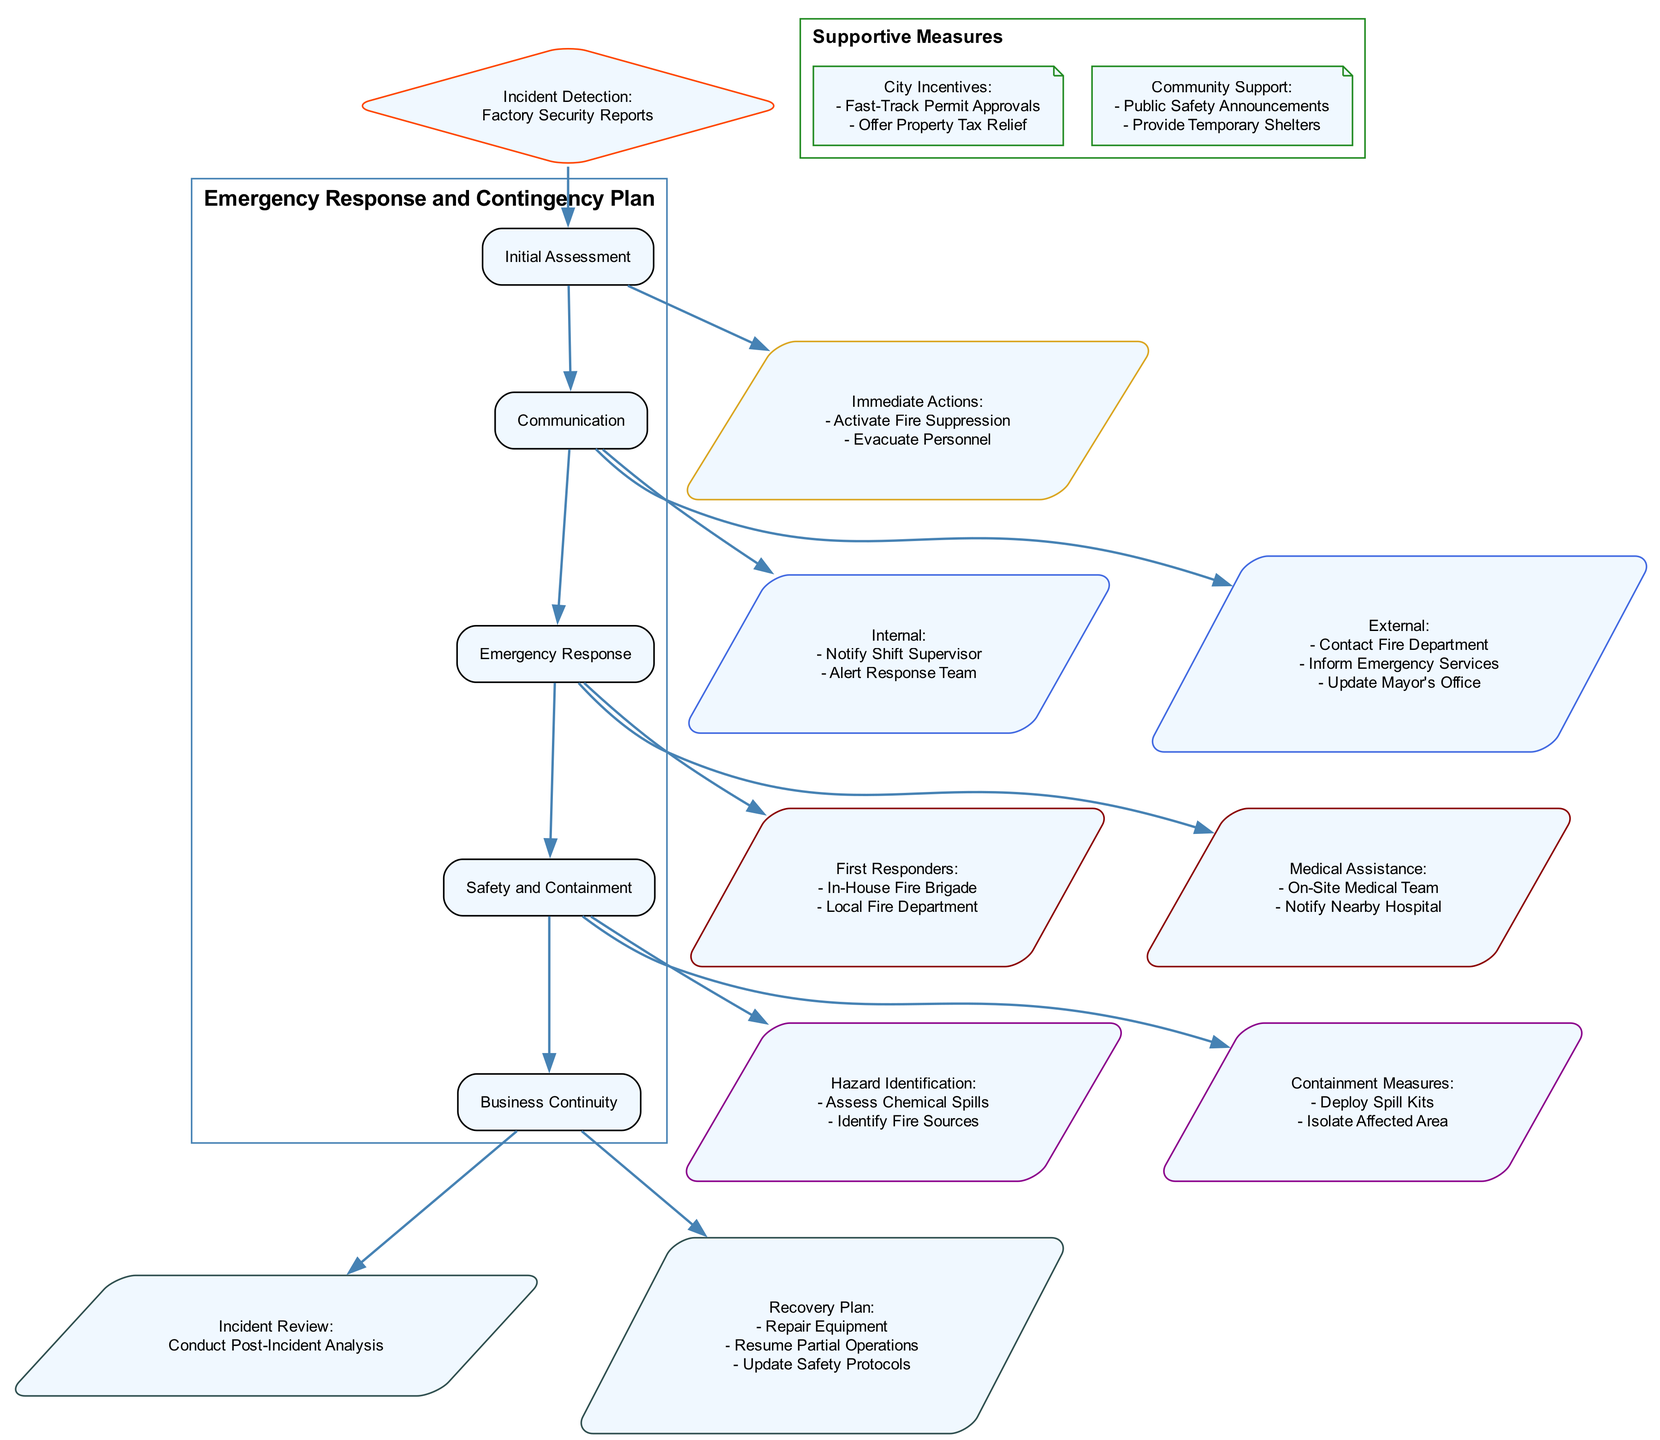What is the first action taken after incident detection? The first action after incident detection is to "Activate Fire Suppression Systems." This is listed under Immediate Actions that follow the Incident Detection node.
Answer: Activate Fire Suppression Systems How many main processes are in the diagram? The diagram has five main processes: Initial Assessment, Communication, Emergency Response, Safety and Containment, and Business Continuity. These can be counted from the main node section of the diagram.
Answer: 5 What will the city offer as part of the supportive measures? The city will offer "Fast-Track Permit Approvals" and "Offer Property Tax Relief" as part of the City Incentives. This information is noted in the Supportive Measures section of the diagram.
Answer: Fast-Track Permit Approvals, Offer Property Tax Relief Which node follows Emergency Response? The node that follows Emergency Response is Safety and Containment. The edge from Emergency Response points directly to this node in the flow of the diagram.
Answer: Safety and Containment What type of team is notified as part of the internal communication? The In-House Response Team is notified as part of the internal communication when an incident occurs. This is specifically mentioned in the Internal Communication section.
Answer: In-House Response Team What are the first responders identified in the Emergency Response plan? The first responders identified are the In-House Fire Brigade and the Local Fire Department. This information is presented in the Emergency Response section of the diagram.
Answer: In-House Fire Brigade, Local Fire Department What does the recovery plan include? The recovery plan includes "Repair Damaged Equipment," "Resume Partial Operations," and "Review and Update Safety Protocols." These actions are detailed in the Recovery Plan node under Business Continuity.
Answer: Repair Damaged Equipment, Resume Partial Operations, Review and Update Safety Protocols What is the role of the local fire department in the communication plan? The local fire department's role is to be contacted as part of the external communication during an incident. This task is specifically listed in the External Communication section of the diagram.
Answer: Contact Local Fire Department How are hazardous situations identified during an emergency? Hazardous situations are identified through "Assess Chemical Spills" and "Identify Fire Sources." These actions are specified under Hazard Identification in the Safety and Containment section.
Answer: Assess Chemical Spills, Identify Fire Sources 